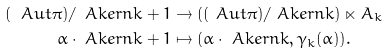Convert formula to latex. <formula><loc_0><loc_0><loc_500><loc_500>( \ A u t \pi ) / \ A k e r { n } { k + 1 } & \to ( ( \ A u t \pi ) / \ A k e r { n } { k } ) \ltimes A _ { k } \\ \alpha \cdot \ A k e r { n } { k + 1 } & \mapsto ( \alpha \cdot \ A k e r { n } { k } , \gamma _ { k } ( \alpha ) ) . \\</formula> 